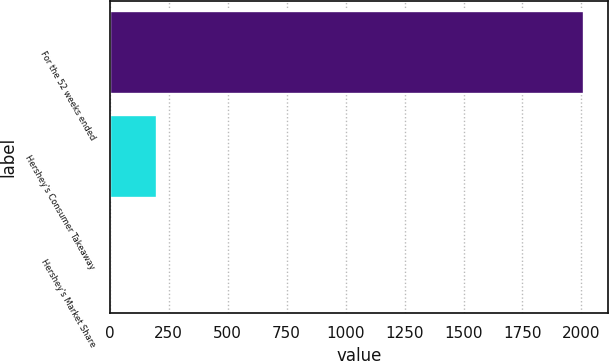Convert chart to OTSL. <chart><loc_0><loc_0><loc_500><loc_500><bar_chart><fcel>For the 52 weeks ended<fcel>Hershey's Consumer Takeaway<fcel>Hershey's Market Share<nl><fcel>2012<fcel>201.74<fcel>0.6<nl></chart> 